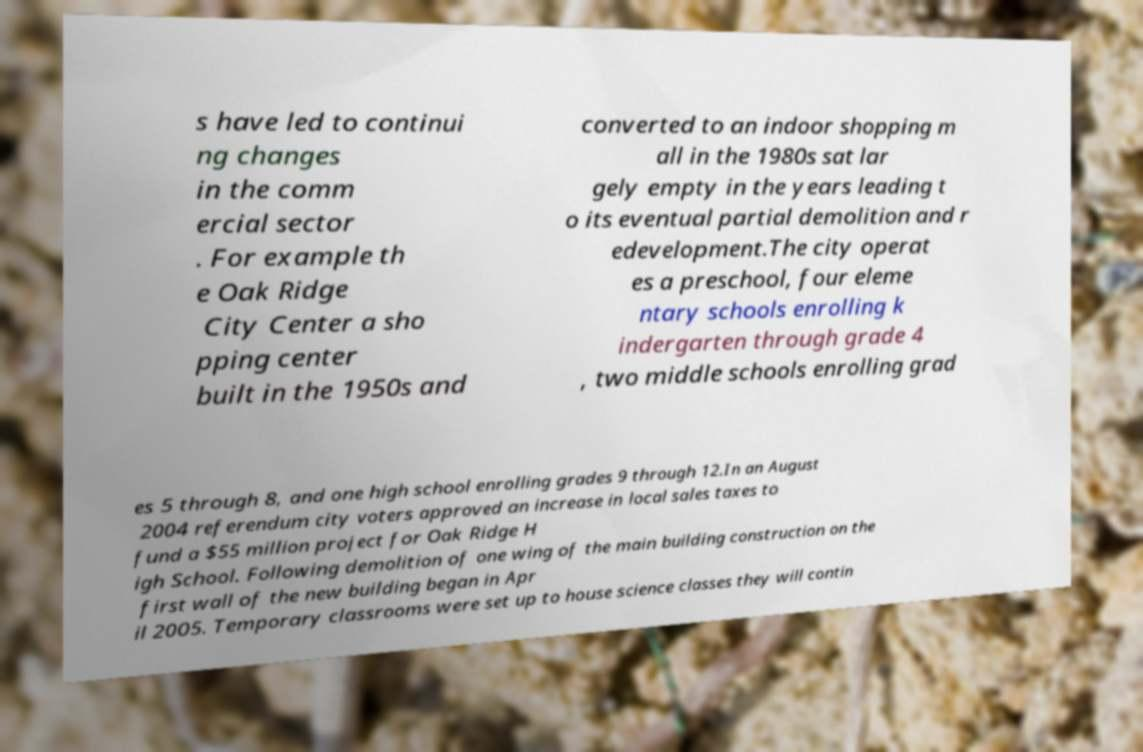For documentation purposes, I need the text within this image transcribed. Could you provide that? s have led to continui ng changes in the comm ercial sector . For example th e Oak Ridge City Center a sho pping center built in the 1950s and converted to an indoor shopping m all in the 1980s sat lar gely empty in the years leading t o its eventual partial demolition and r edevelopment.The city operat es a preschool, four eleme ntary schools enrolling k indergarten through grade 4 , two middle schools enrolling grad es 5 through 8, and one high school enrolling grades 9 through 12.In an August 2004 referendum city voters approved an increase in local sales taxes to fund a $55 million project for Oak Ridge H igh School. Following demolition of one wing of the main building construction on the first wall of the new building began in Apr il 2005. Temporary classrooms were set up to house science classes they will contin 